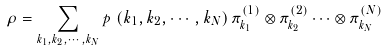Convert formula to latex. <formula><loc_0><loc_0><loc_500><loc_500>\rho = \sum _ { k _ { 1 } , k _ { 2 } , \cdots , k _ { N } } p \, \left ( { k _ { 1 } , k _ { 2 } , \cdots , k _ { N } } \right ) \pi ^ { ( 1 ) } _ { k _ { 1 } } \otimes \pi ^ { ( 2 ) } _ { k _ { 2 } } \cdots \otimes \pi ^ { ( N ) } _ { k _ { N } }</formula> 